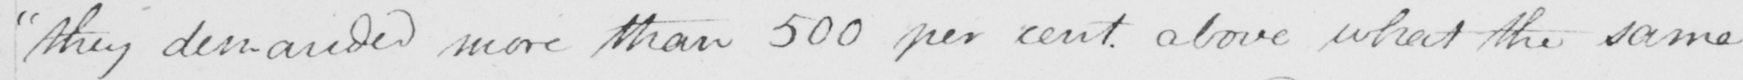What text is written in this handwritten line? they demanded more than 500 per cent above what the same 